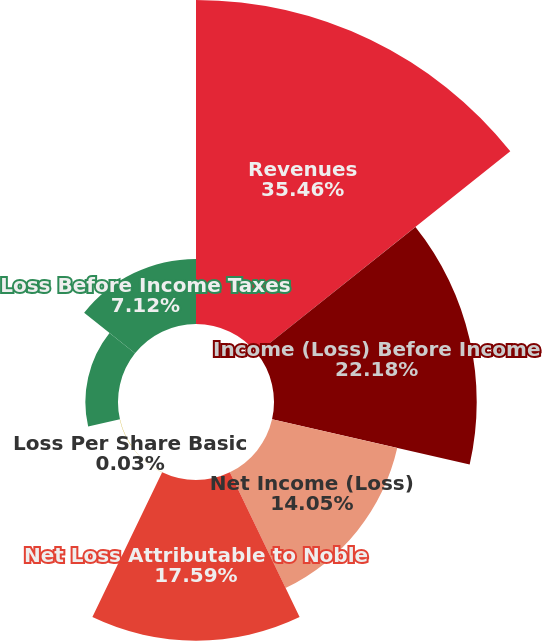Convert chart to OTSL. <chart><loc_0><loc_0><loc_500><loc_500><pie_chart><fcel>Revenues<fcel>Income (Loss) Before Income<fcel>Net Income (Loss)<fcel>Net Loss Attributable to Noble<fcel>Loss Per Share Basic<fcel>Loss Per Share Diluted<fcel>Loss Before Income Taxes<nl><fcel>35.45%<fcel>22.18%<fcel>14.05%<fcel>17.59%<fcel>0.03%<fcel>3.57%<fcel>7.12%<nl></chart> 